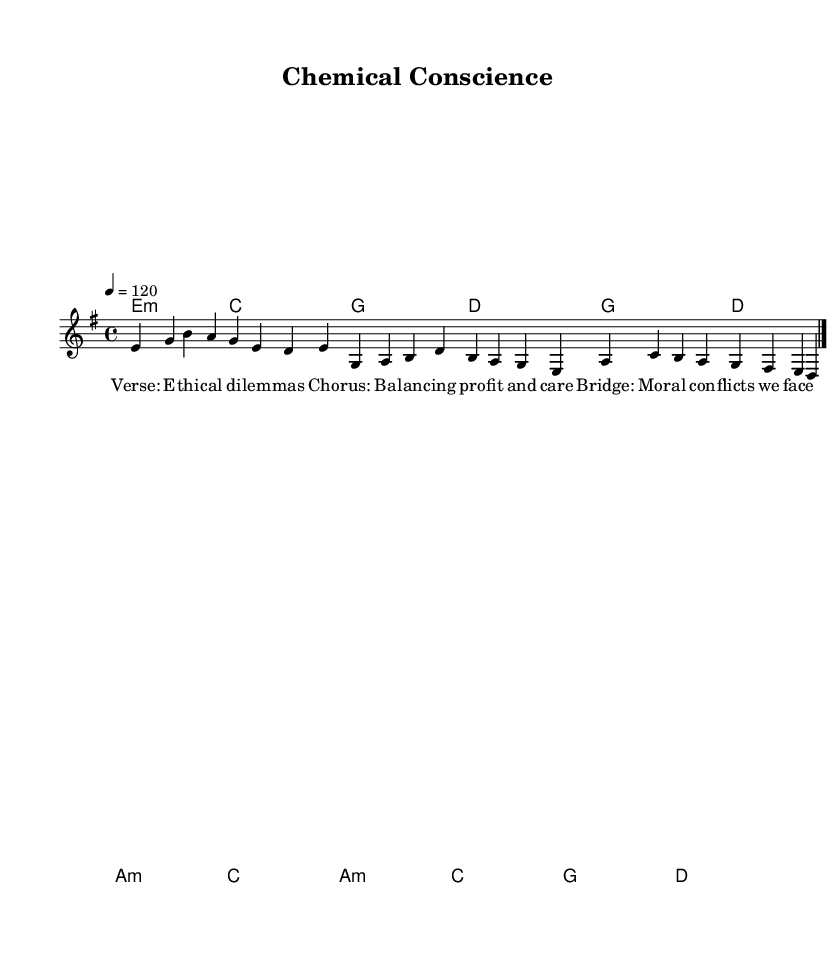What is the key signature of this music? The key signature is E minor, indicated by one sharp (F#) in the key signature box.
Answer: E minor What is the time signature of this music? The time signature is 4/4, which is shown at the beginning of the music. This indicates that there are four beats in each measure, and the quarter note gets the beat.
Answer: 4/4 What is the tempo marking for this piece? The tempo marking is 120 beats per minute, as indicated next to the tempo symbol at the beginning of the score.
Answer: 120 How many sections are there in the song structure? The song structure consists of three distinct sections: a verse, a chorus, and a bridge. Each section is clearly labeled in the lyrics.
Answer: Three What is the purpose of the chord symbols written above the staff? The chord symbols indicate the harmonic progression to accompany the melody, providing structure and context for the piece.
Answer: To guide harmonic accompaniment Which line in the lyrics discusses ethical dilemmas? The lyrics in the verse mention "E -- thi -- cal di -- lem -- mas," explicitly addressing the ethical dilemmas faced in the context of pharmaceutical development.
Answer: Verse 